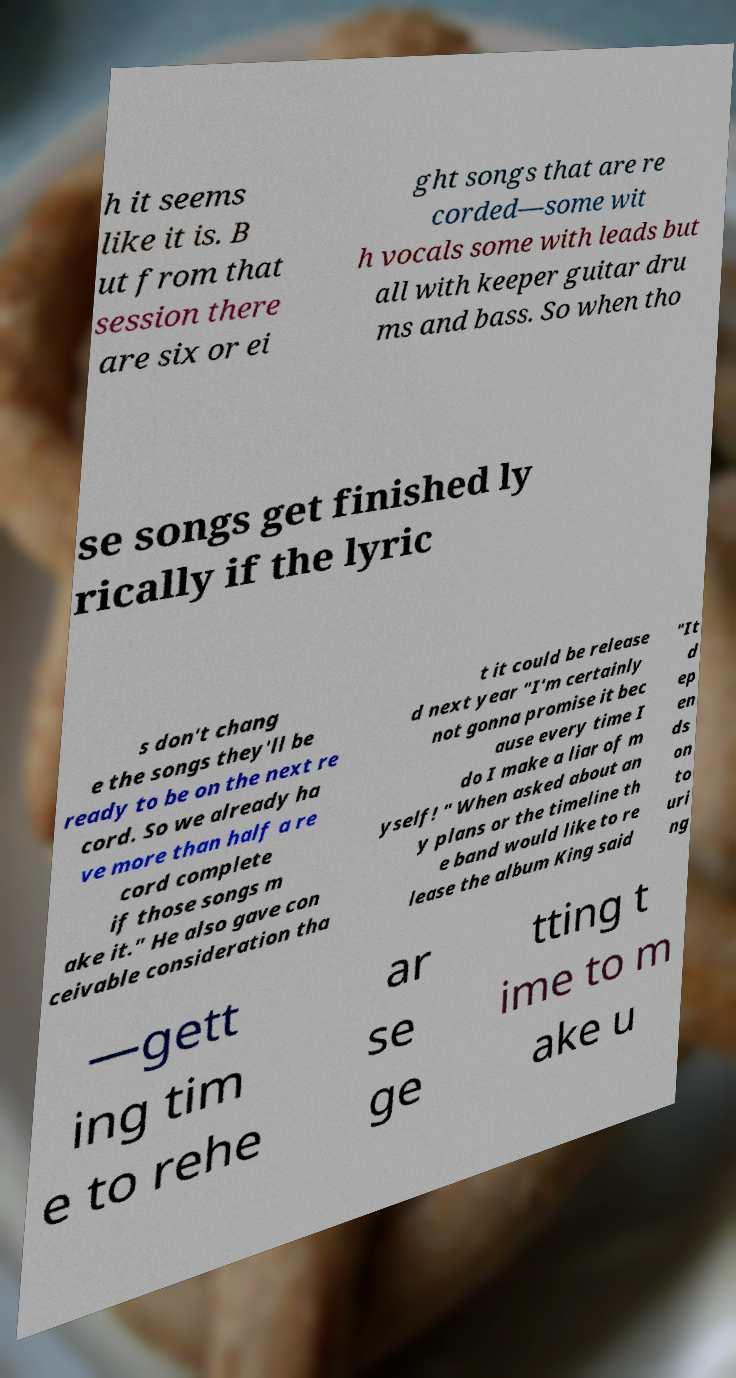Can you accurately transcribe the text from the provided image for me? h it seems like it is. B ut from that session there are six or ei ght songs that are re corded—some wit h vocals some with leads but all with keeper guitar dru ms and bass. So when tho se songs get finished ly rically if the lyric s don't chang e the songs they'll be ready to be on the next re cord. So we already ha ve more than half a re cord complete if those songs m ake it." He also gave con ceivable consideration tha t it could be release d next year "I'm certainly not gonna promise it bec ause every time I do I make a liar of m yself! " When asked about an y plans or the timeline th e band would like to re lease the album King said "It d ep en ds on to uri ng —gett ing tim e to rehe ar se ge tting t ime to m ake u 